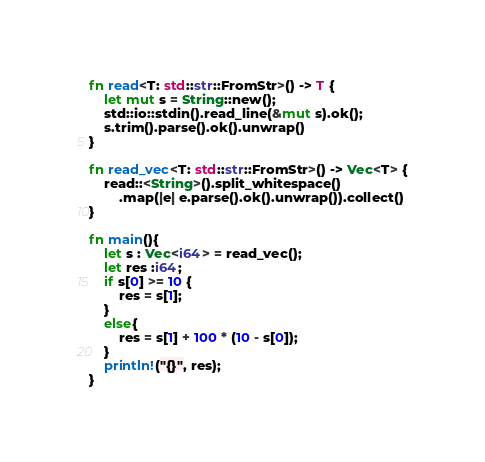<code> <loc_0><loc_0><loc_500><loc_500><_Rust_>fn read<T: std::str::FromStr>() -> T {
    let mut s = String::new();
    std::io::stdin().read_line(&mut s).ok();
    s.trim().parse().ok().unwrap()
}

fn read_vec<T: std::str::FromStr>() -> Vec<T> {
    read::<String>().split_whitespace()
        .map(|e| e.parse().ok().unwrap()).collect()
}

fn main(){
    let s : Vec<i64> = read_vec();
    let res :i64;
    if s[0] >= 10 {
        res = s[1];
    }
    else{
        res = s[1] + 100 * (10 - s[0]);
    }
    println!("{}", res);
}
</code> 